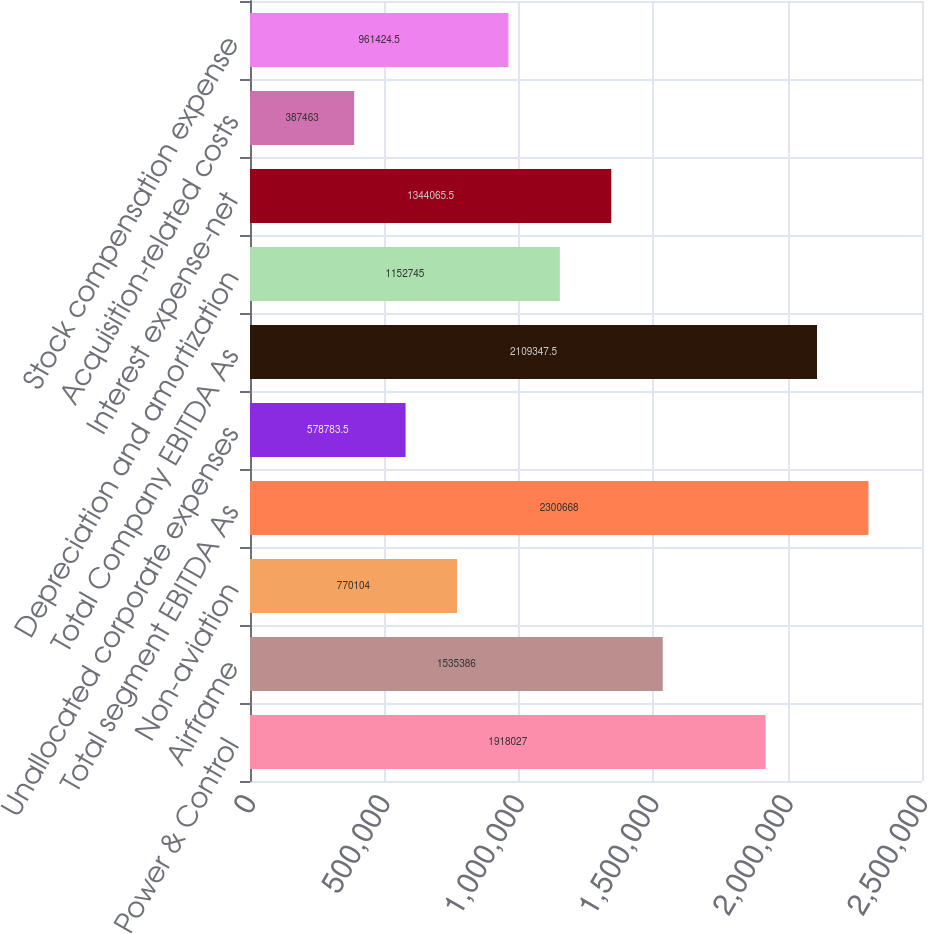Convert chart. <chart><loc_0><loc_0><loc_500><loc_500><bar_chart><fcel>Power & Control<fcel>Airframe<fcel>Non-aviation<fcel>Total segment EBITDA As<fcel>Unallocated corporate expenses<fcel>Total Company EBITDA As<fcel>Depreciation and amortization<fcel>Interest expense-net<fcel>Acquisition-related costs<fcel>Stock compensation expense<nl><fcel>1.91803e+06<fcel>1.53539e+06<fcel>770104<fcel>2.30067e+06<fcel>578784<fcel>2.10935e+06<fcel>1.15274e+06<fcel>1.34407e+06<fcel>387463<fcel>961424<nl></chart> 